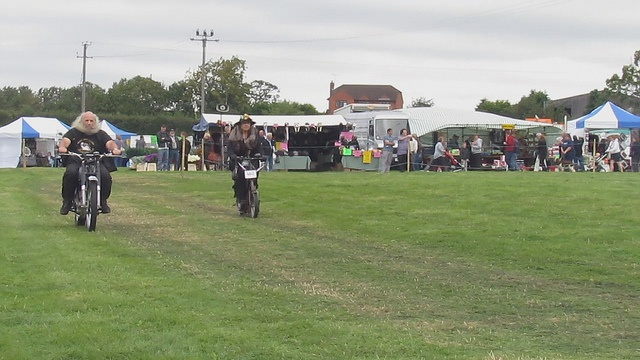Describe the objects in this image and their specific colors. I can see people in lightgray, gray, black, and darkgray tones, people in lightgray, black, gray, darkgray, and tan tones, motorcycle in lightgray, gray, black, and darkgray tones, bus in lightgray, darkgray, and gray tones, and motorcycle in lightgray, black, gray, and darkgray tones in this image. 